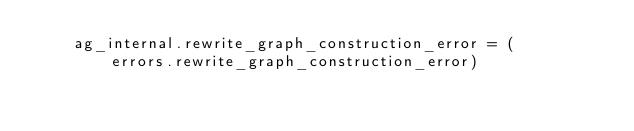<code> <loc_0><loc_0><loc_500><loc_500><_Python_>    ag_internal.rewrite_graph_construction_error = (
        errors.rewrite_graph_construction_error)</code> 